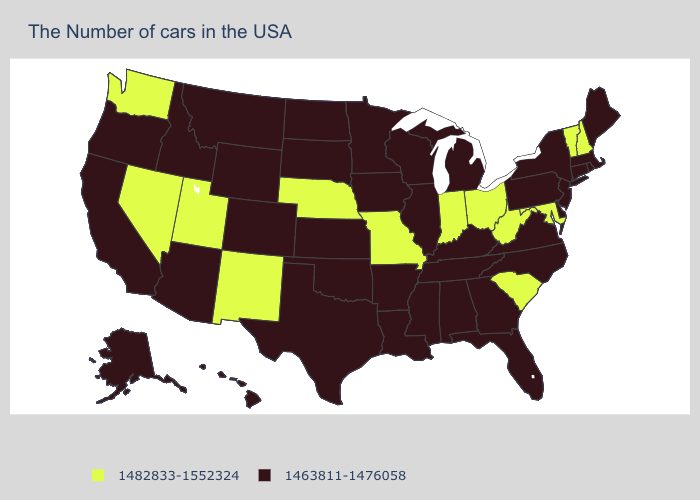How many symbols are there in the legend?
Give a very brief answer. 2. Does Washington have the lowest value in the USA?
Answer briefly. No. Does the first symbol in the legend represent the smallest category?
Answer briefly. No. Does the first symbol in the legend represent the smallest category?
Keep it brief. No. Name the states that have a value in the range 1482833-1552324?
Concise answer only. New Hampshire, Vermont, Maryland, South Carolina, West Virginia, Ohio, Indiana, Missouri, Nebraska, New Mexico, Utah, Nevada, Washington. Name the states that have a value in the range 1463811-1476058?
Be succinct. Maine, Massachusetts, Rhode Island, Connecticut, New York, New Jersey, Delaware, Pennsylvania, Virginia, North Carolina, Florida, Georgia, Michigan, Kentucky, Alabama, Tennessee, Wisconsin, Illinois, Mississippi, Louisiana, Arkansas, Minnesota, Iowa, Kansas, Oklahoma, Texas, South Dakota, North Dakota, Wyoming, Colorado, Montana, Arizona, Idaho, California, Oregon, Alaska, Hawaii. Which states have the lowest value in the USA?
Give a very brief answer. Maine, Massachusetts, Rhode Island, Connecticut, New York, New Jersey, Delaware, Pennsylvania, Virginia, North Carolina, Florida, Georgia, Michigan, Kentucky, Alabama, Tennessee, Wisconsin, Illinois, Mississippi, Louisiana, Arkansas, Minnesota, Iowa, Kansas, Oklahoma, Texas, South Dakota, North Dakota, Wyoming, Colorado, Montana, Arizona, Idaho, California, Oregon, Alaska, Hawaii. Which states hav the highest value in the MidWest?
Write a very short answer. Ohio, Indiana, Missouri, Nebraska. Does Illinois have the highest value in the MidWest?
Answer briefly. No. What is the value of Texas?
Answer briefly. 1463811-1476058. Which states hav the highest value in the Northeast?
Answer briefly. New Hampshire, Vermont. Does Tennessee have the lowest value in the USA?
Answer briefly. Yes. Among the states that border Tennessee , which have the lowest value?
Short answer required. Virginia, North Carolina, Georgia, Kentucky, Alabama, Mississippi, Arkansas. Name the states that have a value in the range 1463811-1476058?
Be succinct. Maine, Massachusetts, Rhode Island, Connecticut, New York, New Jersey, Delaware, Pennsylvania, Virginia, North Carolina, Florida, Georgia, Michigan, Kentucky, Alabama, Tennessee, Wisconsin, Illinois, Mississippi, Louisiana, Arkansas, Minnesota, Iowa, Kansas, Oklahoma, Texas, South Dakota, North Dakota, Wyoming, Colorado, Montana, Arizona, Idaho, California, Oregon, Alaska, Hawaii. Name the states that have a value in the range 1463811-1476058?
Concise answer only. Maine, Massachusetts, Rhode Island, Connecticut, New York, New Jersey, Delaware, Pennsylvania, Virginia, North Carolina, Florida, Georgia, Michigan, Kentucky, Alabama, Tennessee, Wisconsin, Illinois, Mississippi, Louisiana, Arkansas, Minnesota, Iowa, Kansas, Oklahoma, Texas, South Dakota, North Dakota, Wyoming, Colorado, Montana, Arizona, Idaho, California, Oregon, Alaska, Hawaii. 